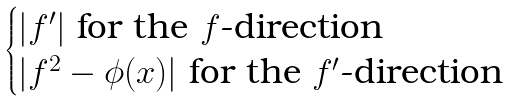Convert formula to latex. <formula><loc_0><loc_0><loc_500><loc_500>\begin{cases} | f ^ { \prime } | \text { for the } f \text {-direction} \\ | f ^ { 2 } - \phi ( x ) | \text { for the } f ^ { \prime } \text {-direction} \\ \end{cases}</formula> 